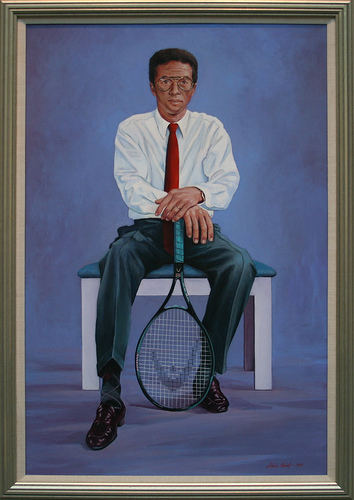Please provide the bounding box coordinate of the region this sentence describes: a man is wearing a burgundy tie. The burgundy tie worn by the man is approximately located within [0.47, 0.24, 0.51, 0.38]. 